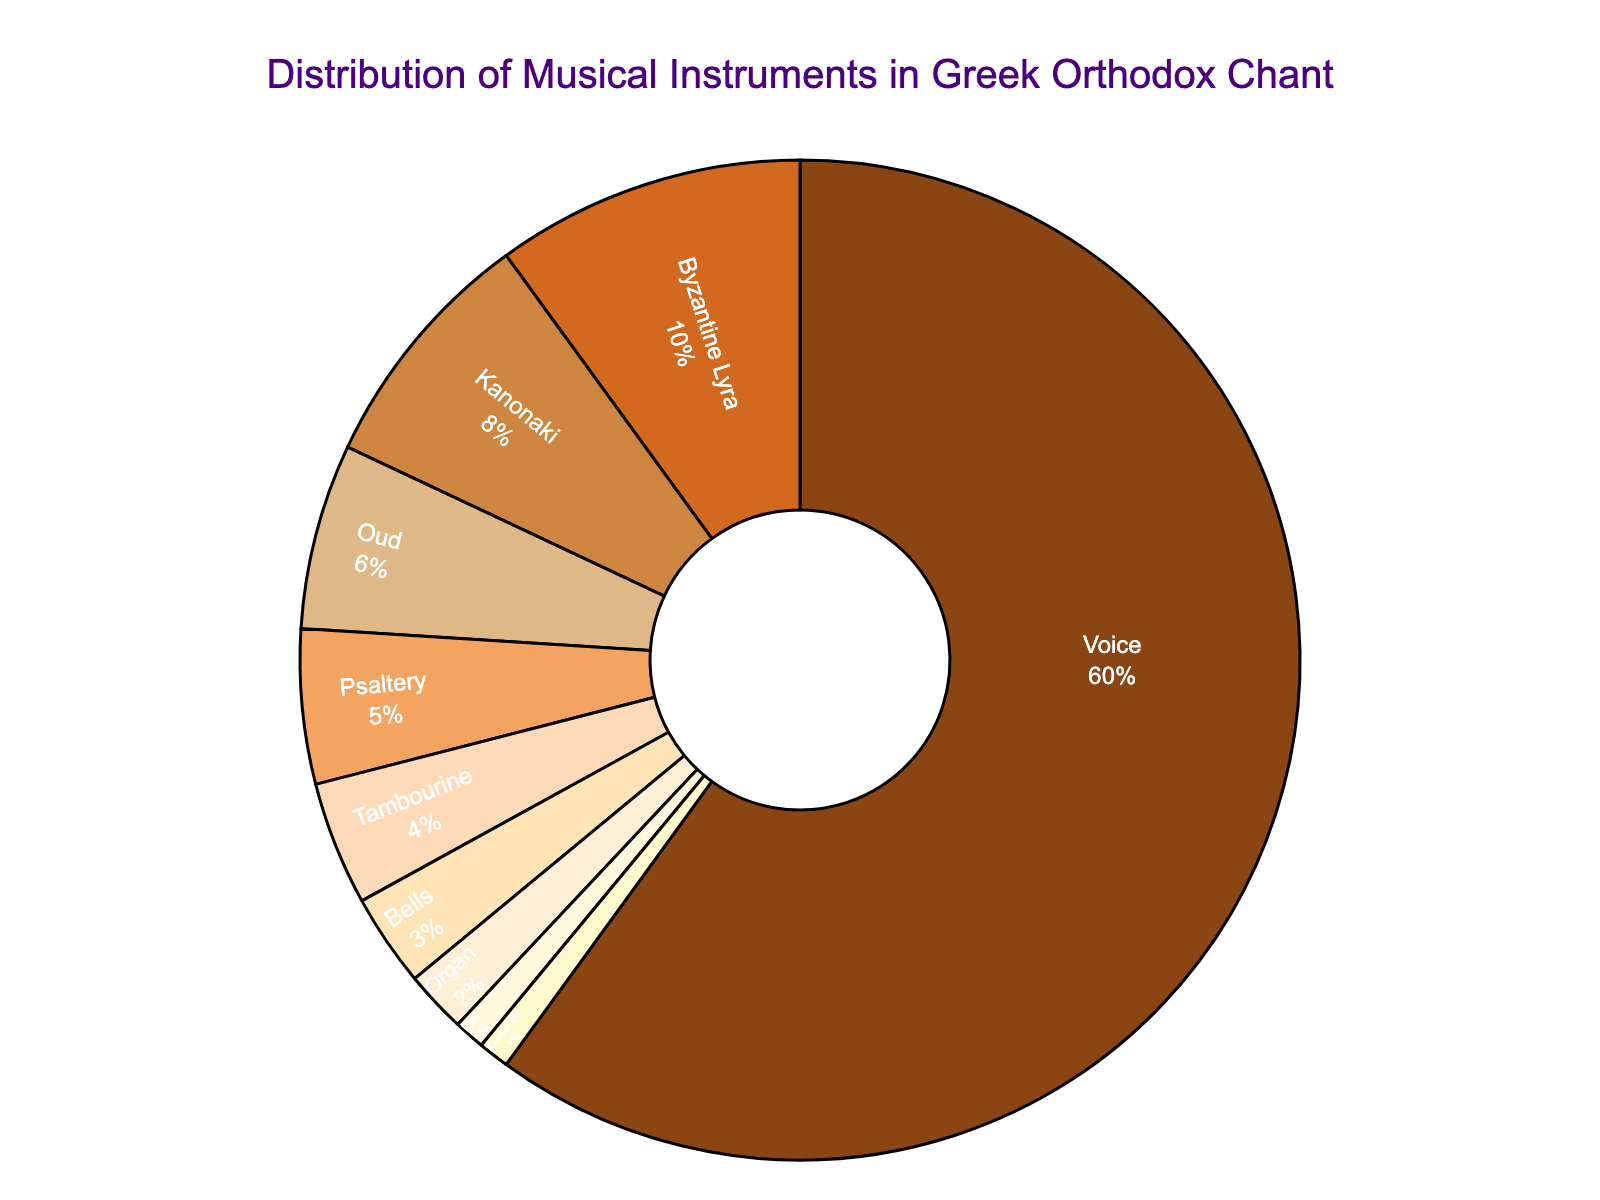Which instrument has the largest percentage in the distribution? Refer to the chart and compare the segments. The "Voice" has the largest segment, making up 60% of the distribution.
Answer: Voice What is the combined percentage of Kanonaki and Oud? Sum the percentages for Kanonaki (8%) and Oud (6%). The combined percentage is 8% + 6% = 14%.
Answer: 14% How many instruments have a percentage of 5% or lower? Identify and count the segments labeled with percentages of 5% or lower: Psaltery (5%), Tambourine (4%), Bells (3%), Organ (2%), Nay (1%), and Kemençe (1%). There are six such instruments.
Answer: 6 Which instruments together constitute more than 80% of the distribution? Start with the instruments with the largest percentages: Voice (60%), Byzantine Lyra (10%), Kanonaki (8%), Oud (6%). Sum these: 60% + 10% + 8% + 6% = 84%, which exceeds 80%.
Answer: Voice, Byzantine Lyra, Kanonaki, Oud Is the percentage of Byzantine Lyra greater than the combined percentage of Bells and Organ? Compare the percentage of Byzantine Lyra (10%) with Bells (3%) + Organ (2%). The combined percentage is 3% + 2% = 5%, which is less than 10%.
Answer: Yes What’s the percentage difference between the instrument with the highest percentage and the instrument with the second highest percentage? The highest is Voice (60%) and the second highest is Byzantine Lyra (10%). The difference is 60% - 10% = 50%.
Answer: 50% Which instruments combined have the smallest share and what is that share? Combine the percentages of Nay (1%) and Kemençe (1%). The combined share is 1% + 1% = 2%.
Answer: Nay, Kemençe; 2% What percentage of the distribution is occupied by percussion instruments? Identify the percussion instruments: Tambourine (4%) and Bells (3%). Sum these percentages: 4% + 3% = 7%.
Answer: 7% How does the percentage of Kanonaki compare to the percentage of Psaltery? Compare the percentages: Kanonaki (8%) and Psaltery (5%). Kanonaki's percentage is higher.
Answer: Kanonaki is higher What is the average percentage of the stringed instruments (Byzantine Lyra, Kanonaki, Oud, and Kemençe)? Sum the percentages: Byzantine Lyra (10%) + Kanonaki (8%) + Oud (6%) + Kemençe (1%) = 25%. There are four stringed instruments, so the average is 25% / 4 = 6.25%.
Answer: 6.25% 